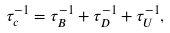Convert formula to latex. <formula><loc_0><loc_0><loc_500><loc_500>\tau _ { c } ^ { - 1 } = \tau _ { B } ^ { - 1 } + \tau _ { D } ^ { - 1 } + \tau _ { U } ^ { - 1 } ,</formula> 